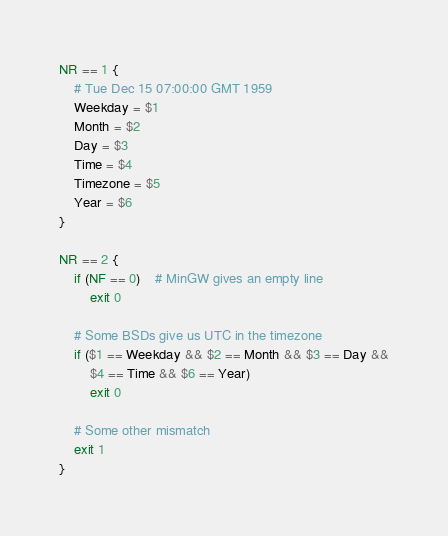<code> <loc_0><loc_0><loc_500><loc_500><_Awk_>NR == 1 {
	# Tue Dec 15 07:00:00 GMT 1959
	Weekday = $1
	Month = $2
	Day = $3
	Time = $4
	Timezone = $5
	Year = $6
}

NR == 2 {
	if (NF == 0)	# MinGW gives an empty line
		exit 0

	# Some BSDs give us UTC in the timezone
	if ($1 == Weekday && $2 == Month && $3 == Day &&
	    $4 == Time && $6 == Year)
		exit 0

	# Some other mismatch
	exit 1
}
</code> 